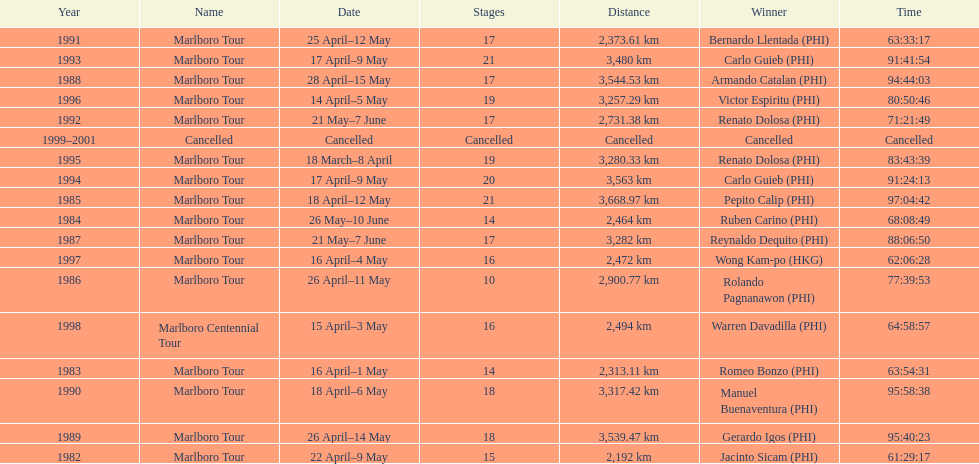What was the largest distance traveled for the marlboro tour? 3,668.97 km. Could you parse the entire table? {'header': ['Year', 'Name', 'Date', 'Stages', 'Distance', 'Winner', 'Time'], 'rows': [['1991', 'Marlboro Tour', '25 April–12 May', '17', '2,373.61\xa0km', 'Bernardo Llentada\xa0(PHI)', '63:33:17'], ['1993', 'Marlboro Tour', '17 April–9 May', '21', '3,480\xa0km', 'Carlo Guieb\xa0(PHI)', '91:41:54'], ['1988', 'Marlboro Tour', '28 April–15 May', '17', '3,544.53\xa0km', 'Armando Catalan\xa0(PHI)', '94:44:03'], ['1996', 'Marlboro Tour', '14 April–5 May', '19', '3,257.29\xa0km', 'Victor Espiritu\xa0(PHI)', '80:50:46'], ['1992', 'Marlboro Tour', '21 May–7 June', '17', '2,731.38\xa0km', 'Renato Dolosa\xa0(PHI)', '71:21:49'], ['1999–2001', 'Cancelled', 'Cancelled', 'Cancelled', 'Cancelled', 'Cancelled', 'Cancelled'], ['1995', 'Marlboro Tour', '18 March–8 April', '19', '3,280.33\xa0km', 'Renato Dolosa\xa0(PHI)', '83:43:39'], ['1994', 'Marlboro Tour', '17 April–9 May', '20', '3,563\xa0km', 'Carlo Guieb\xa0(PHI)', '91:24:13'], ['1985', 'Marlboro Tour', '18 April–12 May', '21', '3,668.97\xa0km', 'Pepito Calip\xa0(PHI)', '97:04:42'], ['1984', 'Marlboro Tour', '26 May–10 June', '14', '2,464\xa0km', 'Ruben Carino\xa0(PHI)', '68:08:49'], ['1987', 'Marlboro Tour', '21 May–7 June', '17', '3,282\xa0km', 'Reynaldo Dequito\xa0(PHI)', '88:06:50'], ['1997', 'Marlboro Tour', '16 April–4 May', '16', '2,472\xa0km', 'Wong Kam-po\xa0(HKG)', '62:06:28'], ['1986', 'Marlboro Tour', '26 April–11 May', '10', '2,900.77\xa0km', 'Rolando Pagnanawon\xa0(PHI)', '77:39:53'], ['1998', 'Marlboro Centennial Tour', '15 April–3 May', '16', '2,494\xa0km', 'Warren Davadilla\xa0(PHI)', '64:58:57'], ['1983', 'Marlboro Tour', '16 April–1 May', '14', '2,313.11\xa0km', 'Romeo Bonzo\xa0(PHI)', '63:54:31'], ['1990', 'Marlboro Tour', '18 April–6 May', '18', '3,317.42\xa0km', 'Manuel Buenaventura\xa0(PHI)', '95:58:38'], ['1989', 'Marlboro Tour', '26 April–14 May', '18', '3,539.47\xa0km', 'Gerardo Igos\xa0(PHI)', '95:40:23'], ['1982', 'Marlboro Tour', '22 April–9 May', '15', '2,192\xa0km', 'Jacinto Sicam\xa0(PHI)', '61:29:17']]} 